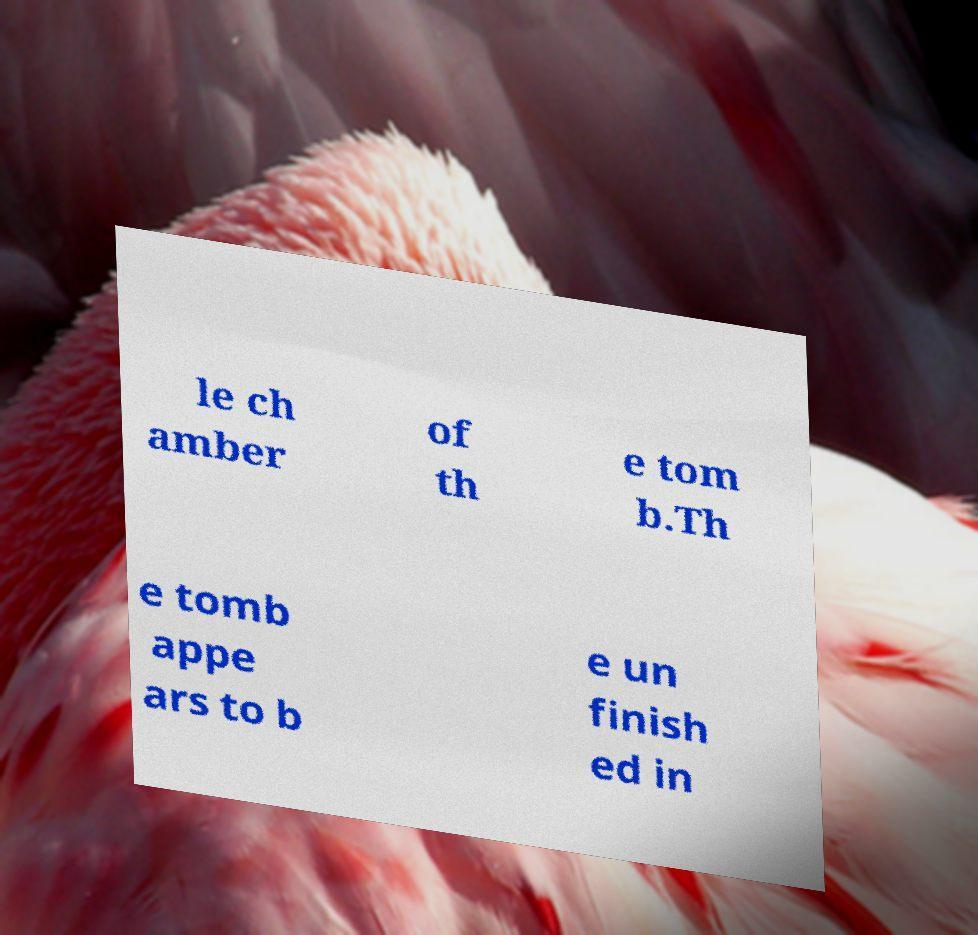Please read and relay the text visible in this image. What does it say? le ch amber of th e tom b.Th e tomb appe ars to b e un finish ed in 